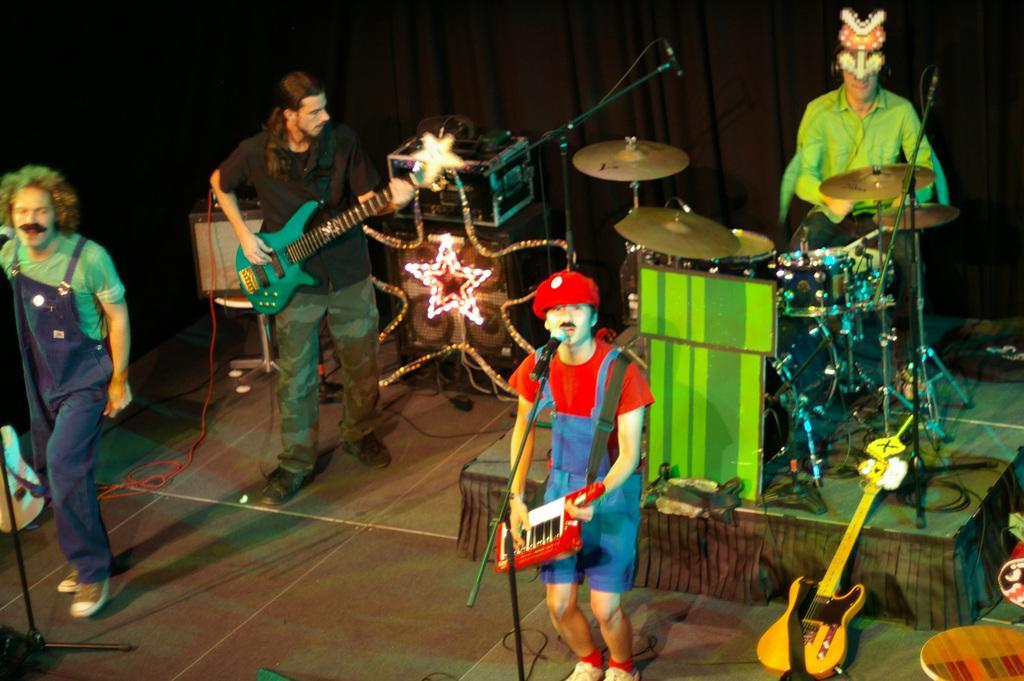Can you describe this image briefly? musical concert is going on. the person at the front is playing keyboard and singing. the person at the left back is playing guitar. the person at the right back is playing drums and wearing a mask. at the right corner there is a guitar in the front. 